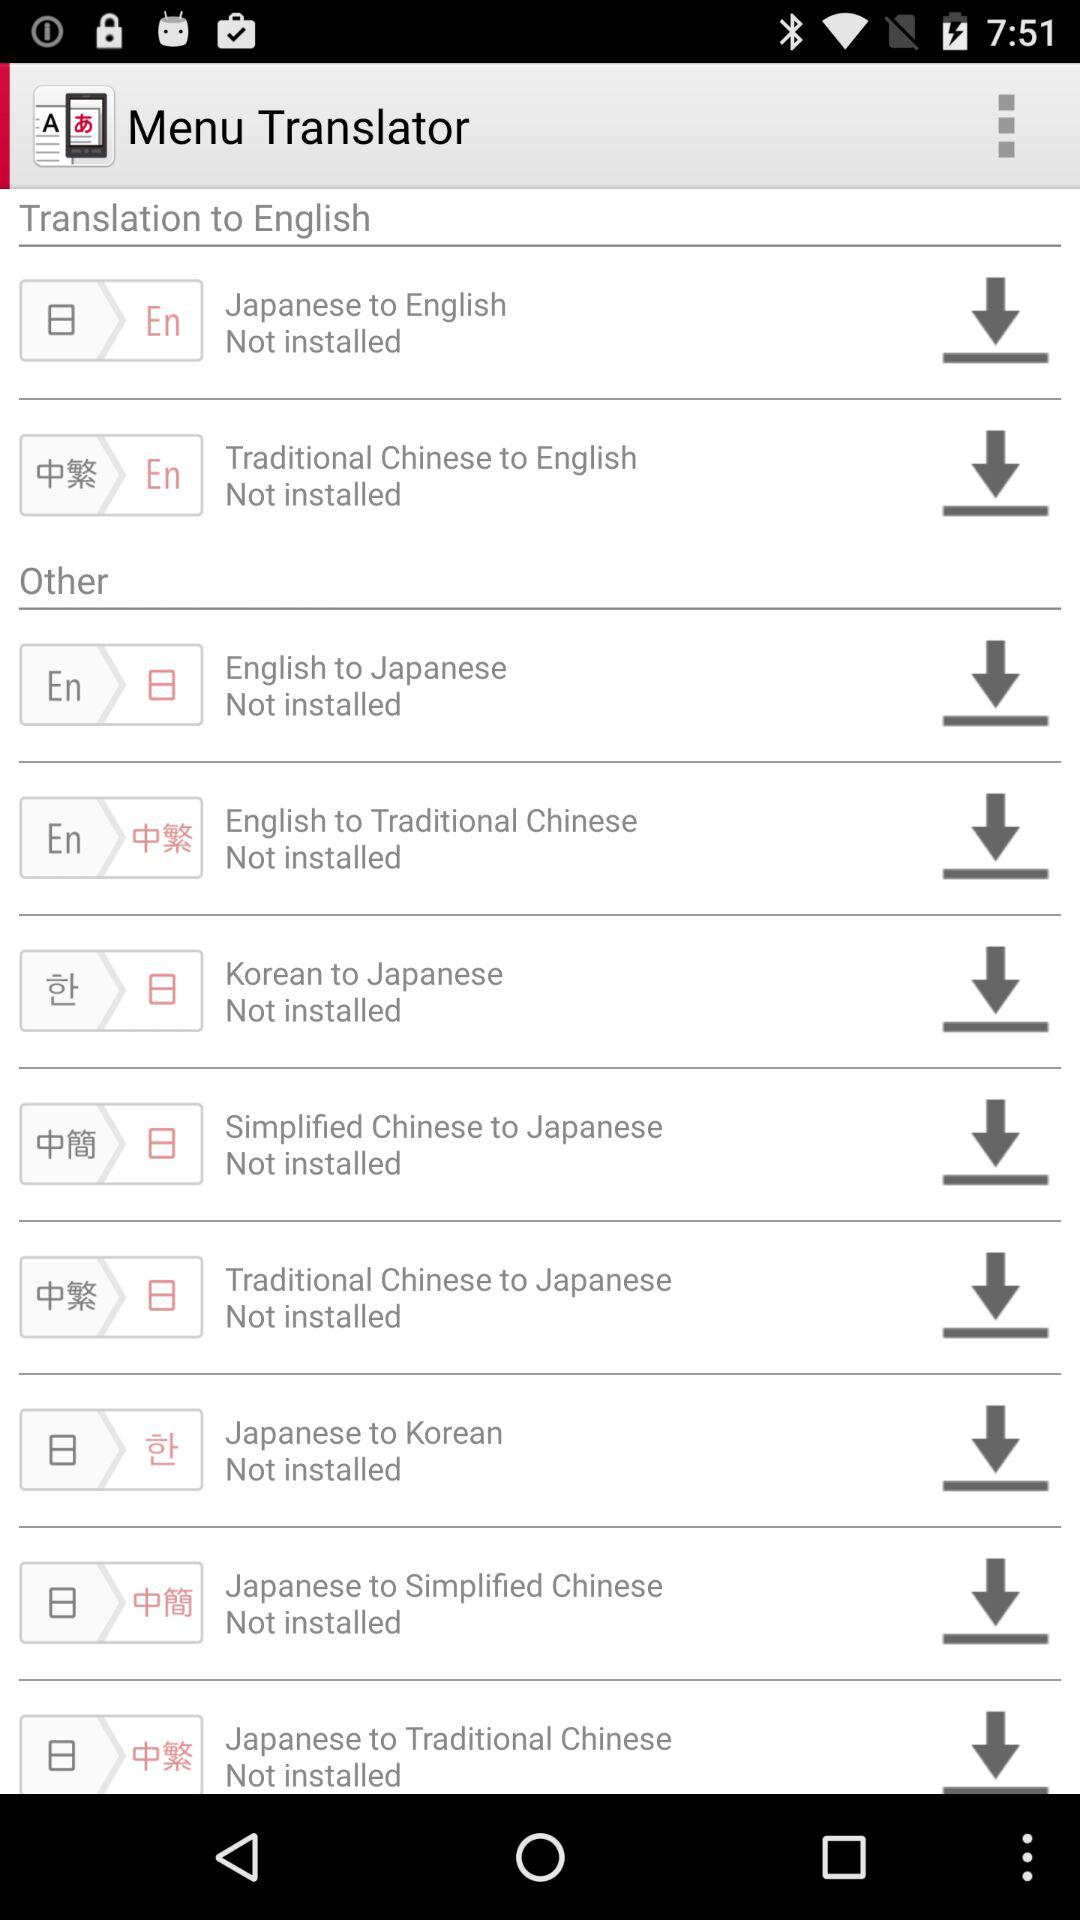What is the application name? The application name is "Menu Translator". 